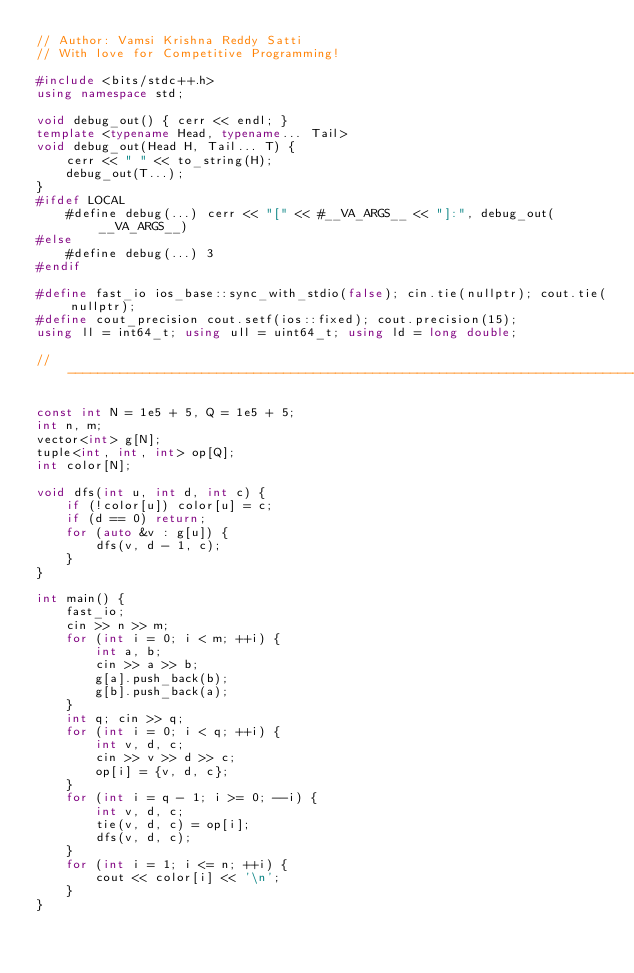Convert code to text. <code><loc_0><loc_0><loc_500><loc_500><_C++_>// Author: Vamsi Krishna Reddy Satti
// With love for Competitive Programming!
 
#include <bits/stdc++.h>
using namespace std;

void debug_out() { cerr << endl; }
template <typename Head, typename... Tail>
void debug_out(Head H, Tail... T) {
    cerr << " " << to_string(H);
    debug_out(T...);
}
#ifdef LOCAL
    #define debug(...) cerr << "[" << #__VA_ARGS__ << "]:", debug_out(__VA_ARGS__)
#else
    #define debug(...) 3
#endif

#define fast_io ios_base::sync_with_stdio(false); cin.tie(nullptr); cout.tie(nullptr);
#define cout_precision cout.setf(ios::fixed); cout.precision(15);
using ll = int64_t; using ull = uint64_t; using ld = long double;

// -----------------------------------------------------------------------------

const int N = 1e5 + 5, Q = 1e5 + 5;
int n, m;
vector<int> g[N];
tuple<int, int, int> op[Q];
int color[N];

void dfs(int u, int d, int c) {
    if (!color[u]) color[u] = c;
    if (d == 0) return;
    for (auto &v : g[u]) {
        dfs(v, d - 1, c);
    }
}

int main() {
    fast_io;
    cin >> n >> m;
    for (int i = 0; i < m; ++i) {
        int a, b;
        cin >> a >> b;
        g[a].push_back(b);
        g[b].push_back(a);
    }
    int q; cin >> q;
    for (int i = 0; i < q; ++i) {
        int v, d, c;
        cin >> v >> d >> c;
        op[i] = {v, d, c};
    }
    for (int i = q - 1; i >= 0; --i) {
        int v, d, c;
        tie(v, d, c) = op[i];
        dfs(v, d, c);
    }
    for (int i = 1; i <= n; ++i) {
        cout << color[i] << '\n';
    }
}
</code> 